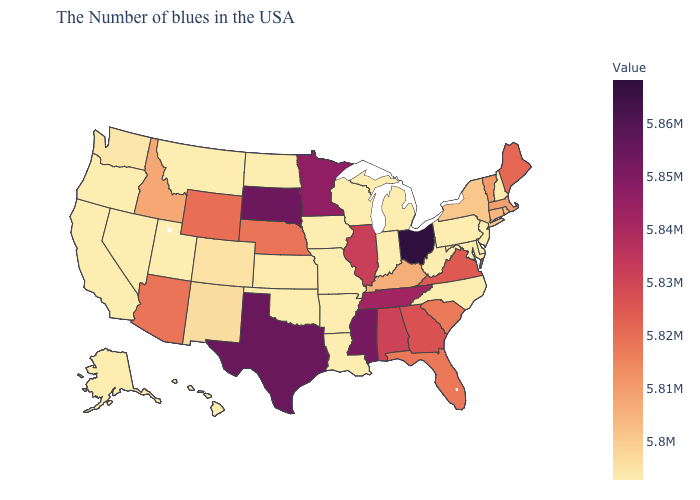Does Wyoming have a lower value than Minnesota?
Quick response, please. Yes. Which states have the lowest value in the MidWest?
Write a very short answer. Michigan, Indiana, Wisconsin, Missouri, Iowa, North Dakota. Does Indiana have the lowest value in the USA?
Short answer required. Yes. Among the states that border Pennsylvania , does Delaware have the lowest value?
Short answer required. Yes. Which states have the highest value in the USA?
Write a very short answer. Ohio. 